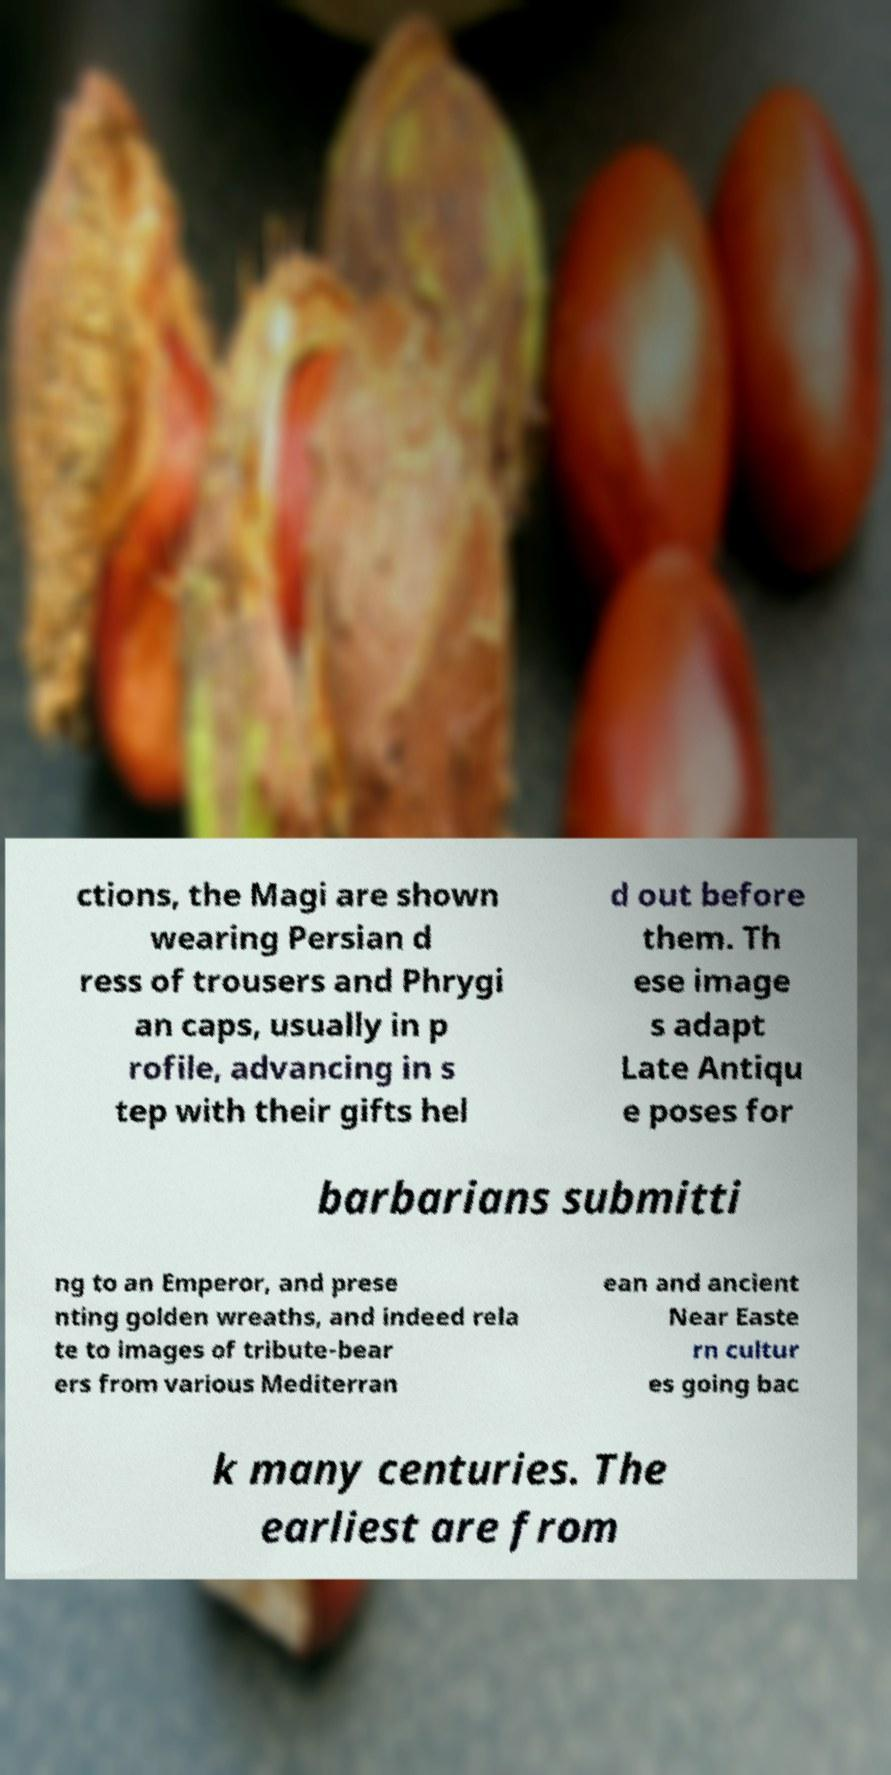What messages or text are displayed in this image? I need them in a readable, typed format. ctions, the Magi are shown wearing Persian d ress of trousers and Phrygi an caps, usually in p rofile, advancing in s tep with their gifts hel d out before them. Th ese image s adapt Late Antiqu e poses for barbarians submitti ng to an Emperor, and prese nting golden wreaths, and indeed rela te to images of tribute-bear ers from various Mediterran ean and ancient Near Easte rn cultur es going bac k many centuries. The earliest are from 